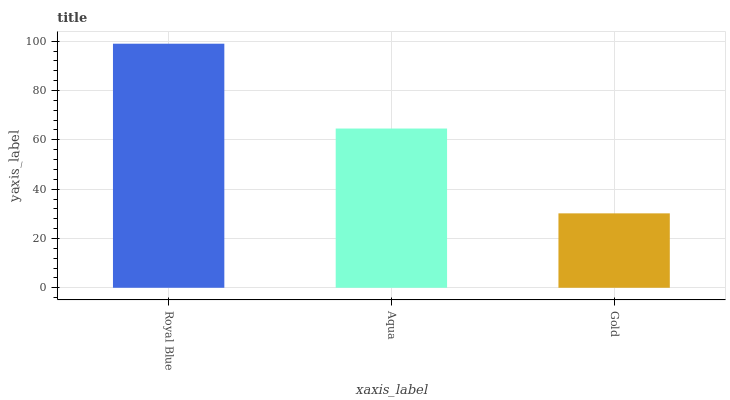Is Aqua the minimum?
Answer yes or no. No. Is Aqua the maximum?
Answer yes or no. No. Is Royal Blue greater than Aqua?
Answer yes or no. Yes. Is Aqua less than Royal Blue?
Answer yes or no. Yes. Is Aqua greater than Royal Blue?
Answer yes or no. No. Is Royal Blue less than Aqua?
Answer yes or no. No. Is Aqua the high median?
Answer yes or no. Yes. Is Aqua the low median?
Answer yes or no. Yes. Is Royal Blue the high median?
Answer yes or no. No. Is Royal Blue the low median?
Answer yes or no. No. 